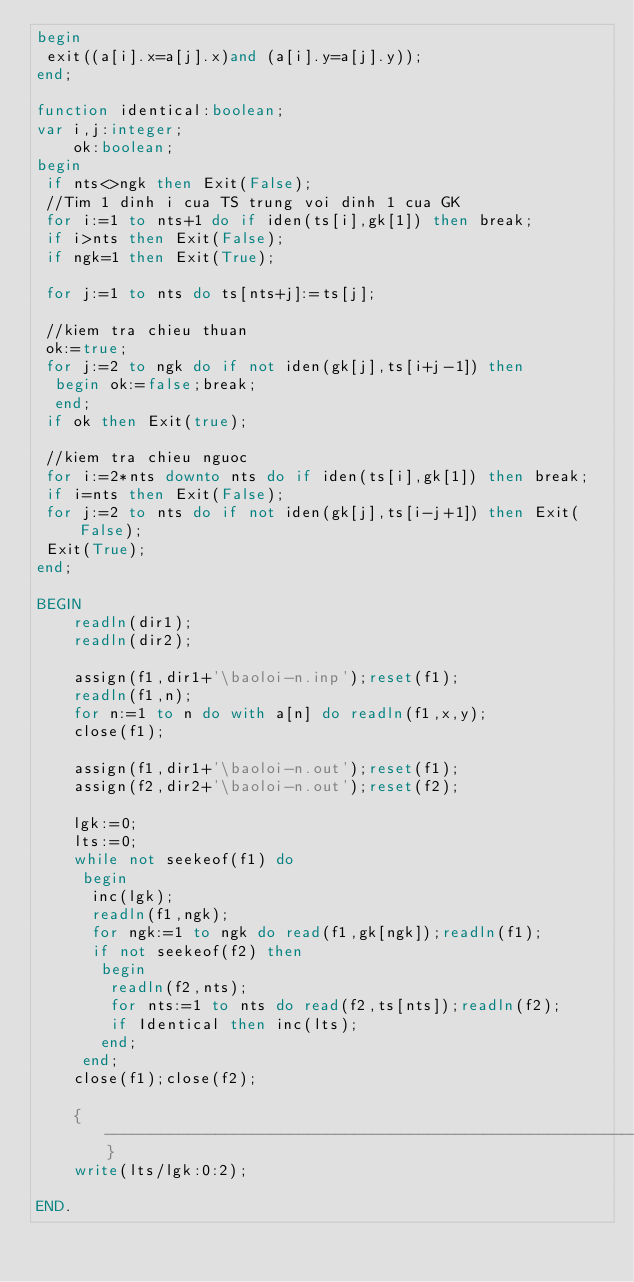<code> <loc_0><loc_0><loc_500><loc_500><_Pascal_>begin
 exit((a[i].x=a[j].x)and (a[i].y=a[j].y));
end;

function identical:boolean;
var i,j:integer;
    ok:boolean;
begin
 if nts<>ngk then Exit(False);
 //Tim 1 dinh i cua TS trung voi dinh 1 cua GK
 for i:=1 to nts+1 do if iden(ts[i],gk[1]) then break;
 if i>nts then Exit(False);
 if ngk=1 then Exit(True);

 for j:=1 to nts do ts[nts+j]:=ts[j];

 //kiem tra chieu thuan
 ok:=true;
 for j:=2 to ngk do if not iden(gk[j],ts[i+j-1]) then
  begin ok:=false;break;
  end;
 if ok then Exit(true);

 //kiem tra chieu nguoc
 for i:=2*nts downto nts do if iden(ts[i],gk[1]) then break;
 if i=nts then Exit(False);
 for j:=2 to nts do if not iden(gk[j],ts[i-j+1]) then Exit(False);
 Exit(True);
end;

BEGIN
    readln(dir1);
    readln(dir2);

    assign(f1,dir1+'\baoloi-n.inp');reset(f1);
    readln(f1,n);
    for n:=1 to n do with a[n] do readln(f1,x,y);
    close(f1);

    assign(f1,dir1+'\baoloi-n.out');reset(f1);
    assign(f2,dir2+'\baoloi-n.out');reset(f2);

    lgk:=0;
    lts:=0;
    while not seekeof(f1) do
     begin
      inc(lgk);
      readln(f1,ngk);
      for ngk:=1 to ngk do read(f1,gk[ngk]);readln(f1);
      if not seekeof(f2) then
       begin
        readln(f2,nts);
        for nts:=1 to nts do read(f2,ts[nts]);readln(f2);
        if Identical then inc(lts);
       end;
     end;
    close(f1);close(f2);

    {------------------------------------------------------------}
    write(lts/lgk:0:2);

END.
</code> 